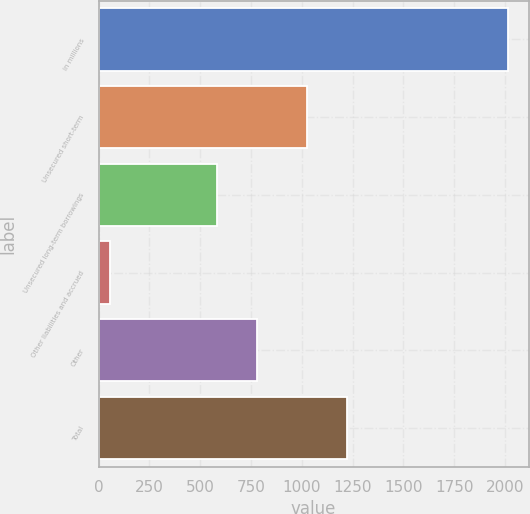<chart> <loc_0><loc_0><loc_500><loc_500><bar_chart><fcel>in millions<fcel>Unsecured short-term<fcel>Unsecured long-term borrowings<fcel>Other liabilities and accrued<fcel>Other<fcel>Total<nl><fcel>2016<fcel>1028<fcel>584<fcel>55<fcel>780.1<fcel>1224.1<nl></chart> 